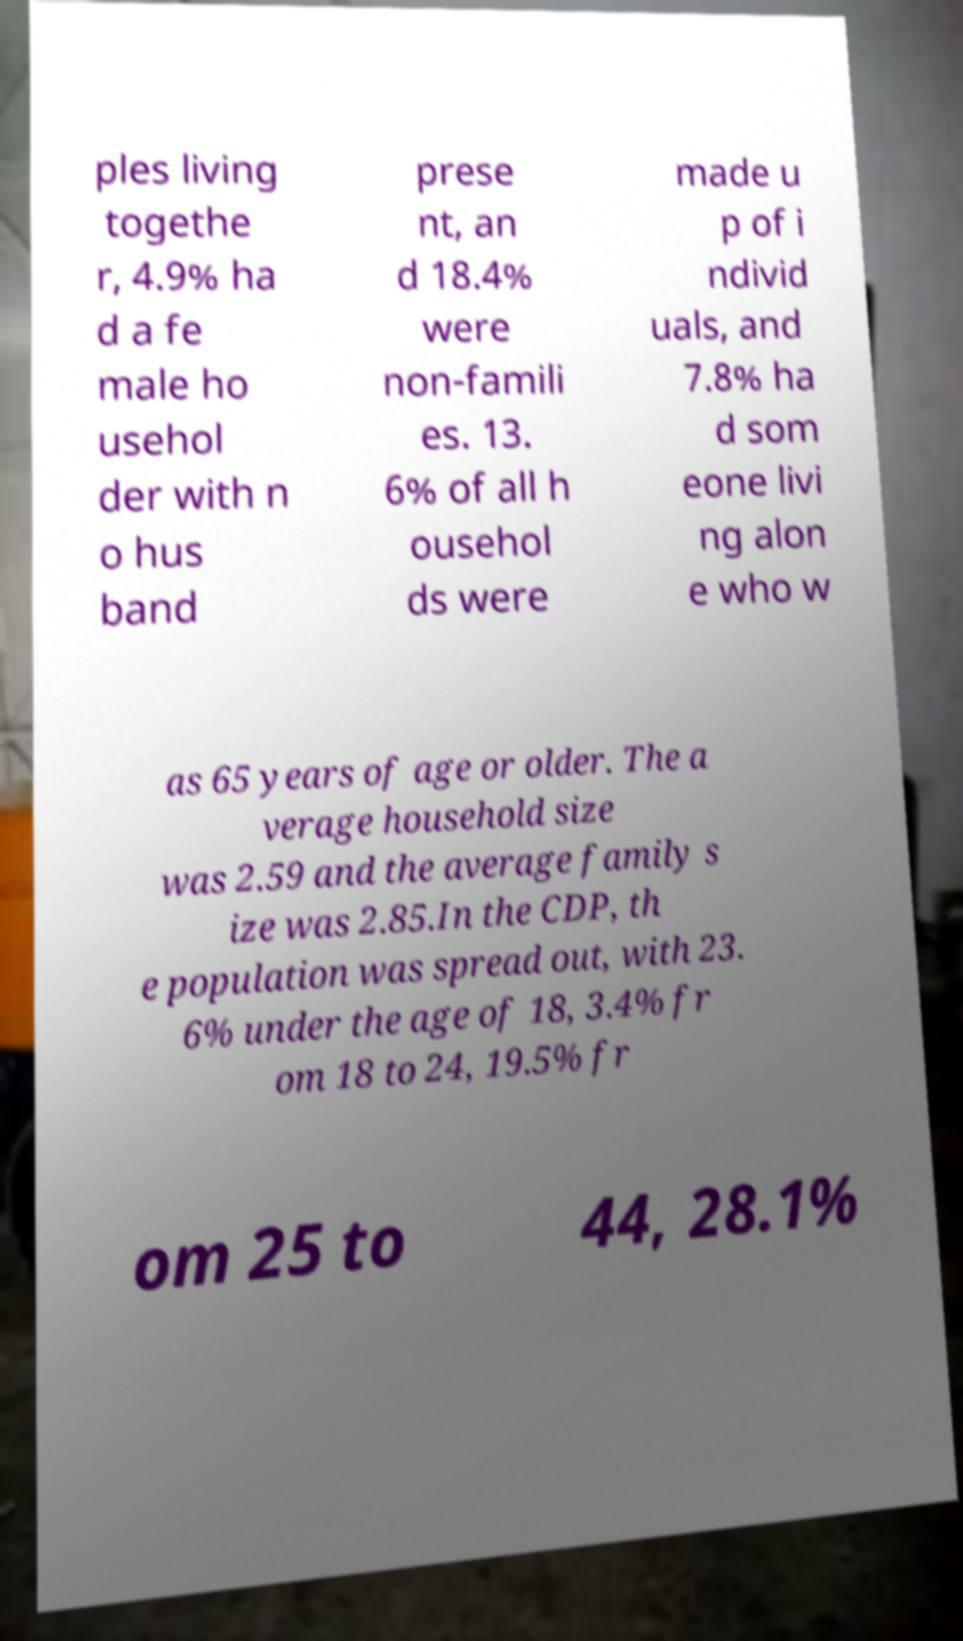I need the written content from this picture converted into text. Can you do that? ples living togethe r, 4.9% ha d a fe male ho usehol der with n o hus band prese nt, an d 18.4% were non-famili es. 13. 6% of all h ousehol ds were made u p of i ndivid uals, and 7.8% ha d som eone livi ng alon e who w as 65 years of age or older. The a verage household size was 2.59 and the average family s ize was 2.85.In the CDP, th e population was spread out, with 23. 6% under the age of 18, 3.4% fr om 18 to 24, 19.5% fr om 25 to 44, 28.1% 